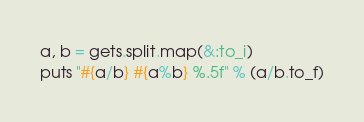Convert code to text. <code><loc_0><loc_0><loc_500><loc_500><_Ruby_>a, b = gets.split.map(&:to_i)
puts "#{a/b} #{a%b} %.5f" % (a/b.to_f)</code> 